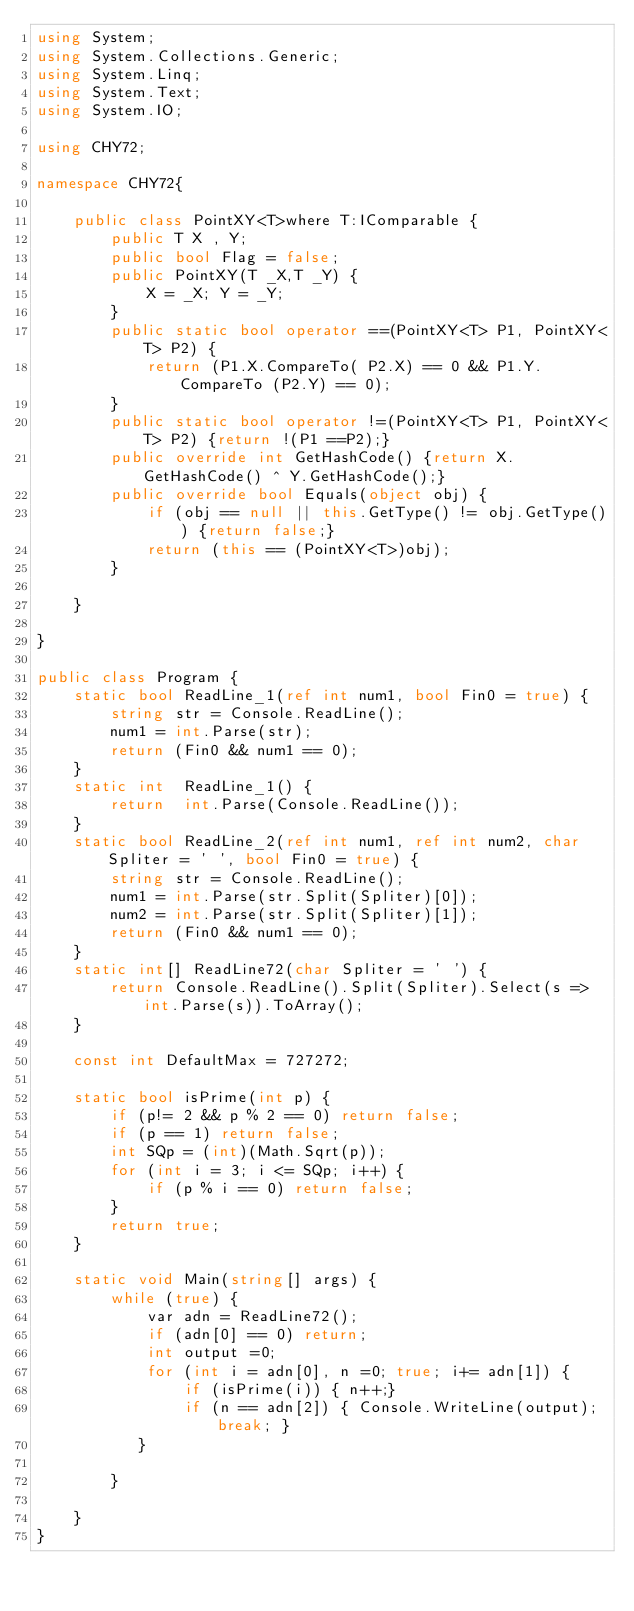Convert code to text. <code><loc_0><loc_0><loc_500><loc_500><_C#_>using System;
using System.Collections.Generic;
using System.Linq;
using System.Text;
using System.IO;

using CHY72;

namespace CHY72{
    
    public class PointXY<T>where T:IComparable {
        public T X , Y;
        public bool Flag = false;
        public PointXY(T _X,T _Y) {
            X = _X; Y = _Y;
        }
        public static bool operator ==(PointXY<T> P1, PointXY<T> P2) {
            return (P1.X.CompareTo( P2.X) == 0 && P1.Y.CompareTo (P2.Y) == 0);
        }
        public static bool operator !=(PointXY<T> P1, PointXY<T> P2) {return !(P1 ==P2);}
        public override int GetHashCode() {return X.GetHashCode() ^ Y.GetHashCode();}
        public override bool Equals(object obj) {
            if (obj == null || this.GetType() != obj.GetType()) {return false;}
            return (this == (PointXY<T>)obj);
        }         

    }
    
}    

public class Program {
    static bool ReadLine_1(ref int num1, bool Fin0 = true) {
        string str = Console.ReadLine();
        num1 = int.Parse(str);
        return (Fin0 && num1 == 0);
    }
    static int  ReadLine_1() {
        return  int.Parse(Console.ReadLine());
    }
    static bool ReadLine_2(ref int num1, ref int num2, char Spliter = ' ', bool Fin0 = true) {
        string str = Console.ReadLine();
        num1 = int.Parse(str.Split(Spliter)[0]);
        num2 = int.Parse(str.Split(Spliter)[1]);
        return (Fin0 && num1 == 0);
    }
    static int[] ReadLine72(char Spliter = ' ') {
        return Console.ReadLine().Split(Spliter).Select(s => int.Parse(s)).ToArray();
    }

    const int DefaultMax = 727272;

    static bool isPrime(int p) {
        if (p!= 2 && p % 2 == 0) return false;
        if (p == 1) return false;
        int SQp = (int)(Math.Sqrt(p));
        for (int i = 3; i <= SQp; i++) {
            if (p % i == 0) return false;
        }
        return true;
    } 

    static void Main(string[] args) {
        while (true) {
            var adn = ReadLine72();
            if (adn[0] == 0) return;
            int output =0;
            for (int i = adn[0], n =0; true; i+= adn[1]) {
                if (isPrime(i)) { n++;}
                if (n == adn[2]) { Console.WriteLine(output); break; }
           }
            
        }

    }
}</code> 